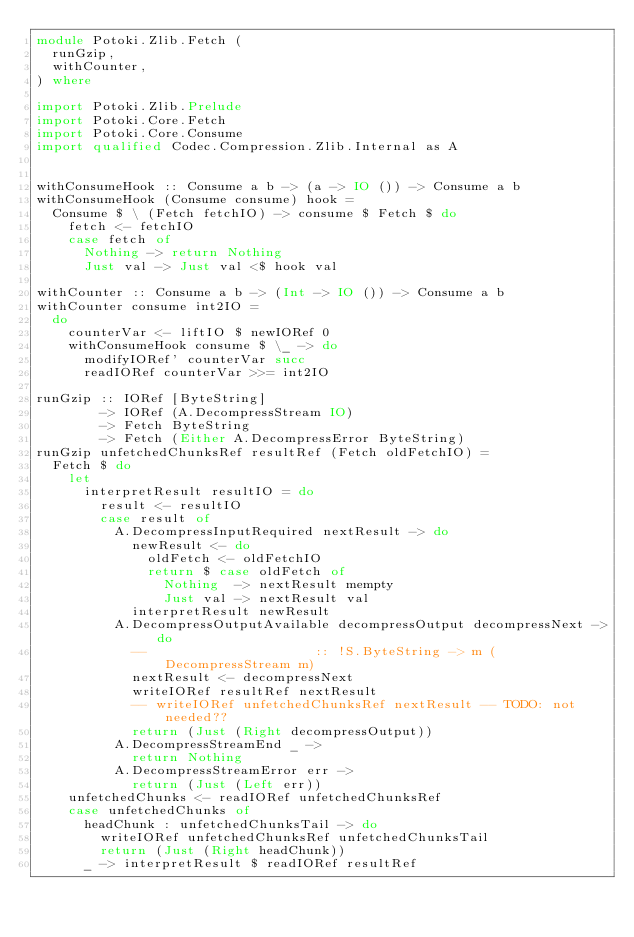<code> <loc_0><loc_0><loc_500><loc_500><_Haskell_>module Potoki.Zlib.Fetch (
  runGzip,
  withCounter,
) where

import Potoki.Zlib.Prelude
import Potoki.Core.Fetch
import Potoki.Core.Consume
import qualified Codec.Compression.Zlib.Internal as A


withConsumeHook :: Consume a b -> (a -> IO ()) -> Consume a b
withConsumeHook (Consume consume) hook =
  Consume $ \ (Fetch fetchIO) -> consume $ Fetch $ do
    fetch <- fetchIO
    case fetch of
      Nothing -> return Nothing
      Just val -> Just val <$ hook val

withCounter :: Consume a b -> (Int -> IO ()) -> Consume a b
withCounter consume int2IO =
  do
    counterVar <- liftIO $ newIORef 0
    withConsumeHook consume $ \_ -> do
      modifyIORef' counterVar succ
      readIORef counterVar >>= int2IO

runGzip :: IORef [ByteString]
        -> IORef (A.DecompressStream IO)
        -> Fetch ByteString
        -> Fetch (Either A.DecompressError ByteString)
runGzip unfetchedChunksRef resultRef (Fetch oldFetchIO) =
  Fetch $ do
    let
      interpretResult resultIO = do
        result <- resultIO
        case result of
          A.DecompressInputRequired nextResult -> do
            newResult <- do
              oldFetch <- oldFetchIO
              return $ case oldFetch of
                Nothing  -> nextResult mempty
                Just val -> nextResult val
            interpretResult newResult
          A.DecompressOutputAvailable decompressOutput decompressNext -> do
            --                     :: !S.ByteString -> m (DecompressStream m)
            nextResult <- decompressNext
            writeIORef resultRef nextResult
            -- writeIORef unfetchedChunksRef nextResult -- TODO: not needed??
            return (Just (Right decompressOutput))
          A.DecompressStreamEnd _ ->
            return Nothing
          A.DecompressStreamError err ->
            return (Just (Left err))
    unfetchedChunks <- readIORef unfetchedChunksRef
    case unfetchedChunks of
      headChunk : unfetchedChunksTail -> do
        writeIORef unfetchedChunksRef unfetchedChunksTail
        return (Just (Right headChunk))
      _ -> interpretResult $ readIORef resultRef
</code> 